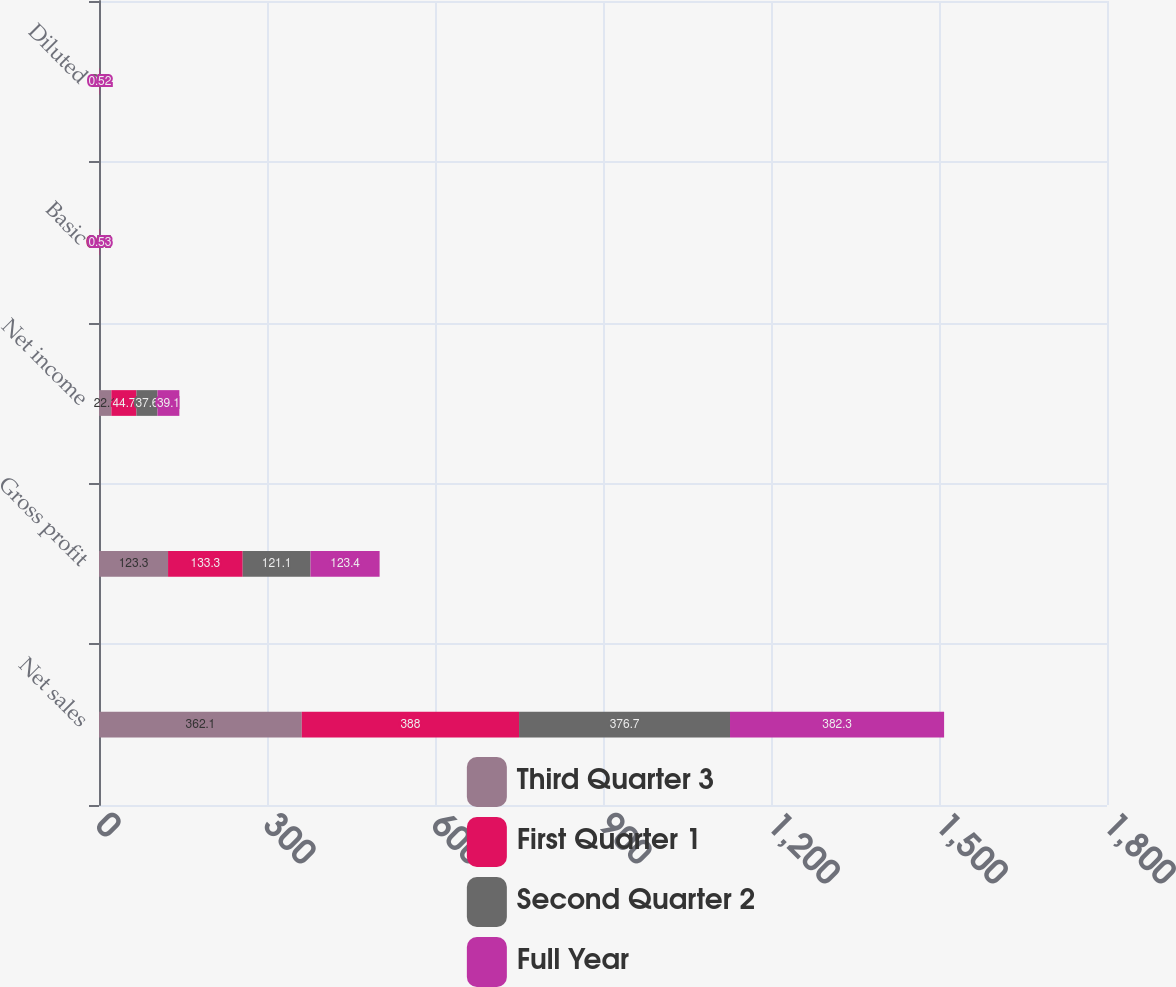Convert chart. <chart><loc_0><loc_0><loc_500><loc_500><stacked_bar_chart><ecel><fcel>Net sales<fcel>Gross profit<fcel>Net income<fcel>Basic<fcel>Diluted<nl><fcel>Third Quarter 3<fcel>362.1<fcel>123.3<fcel>22.1<fcel>0.31<fcel>0.3<nl><fcel>First Quarter 1<fcel>388<fcel>133.3<fcel>44.7<fcel>0.61<fcel>0.6<nl><fcel>Second Quarter 2<fcel>376.7<fcel>121.1<fcel>37.6<fcel>0.51<fcel>0.5<nl><fcel>Full Year<fcel>382.3<fcel>123.4<fcel>39.1<fcel>0.53<fcel>0.52<nl></chart> 